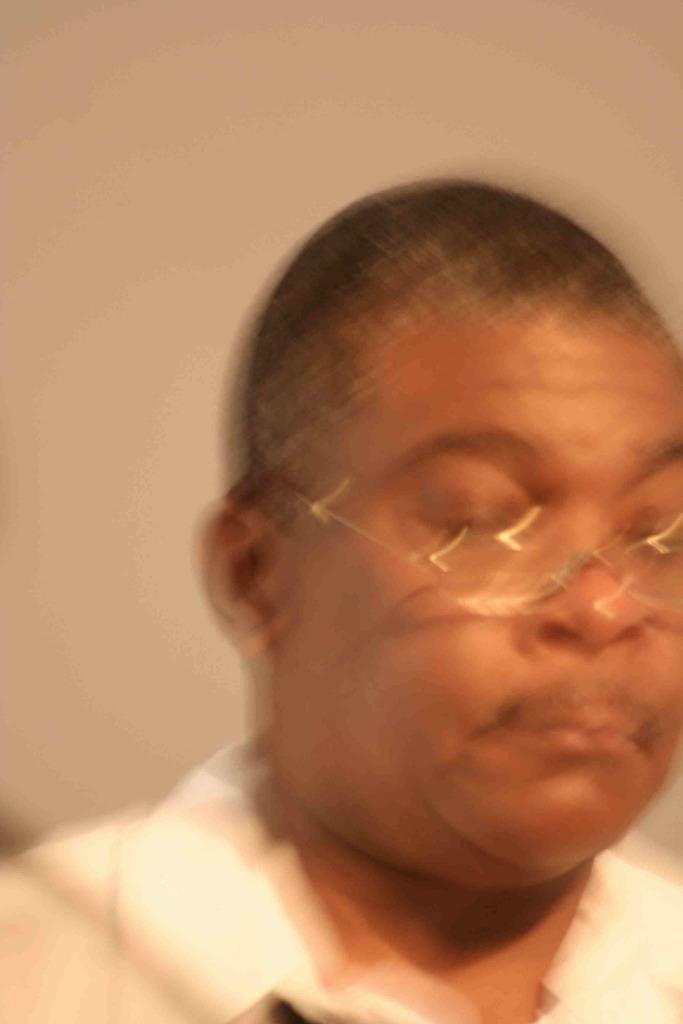What is present in the image? There is a man in the image. Can you describe the man's appearance? The man is wearing spectacles. What type of nail is the man using to hang a coat in the image? There is no nail or coat present in the image; it only features a man wearing spectacles. 